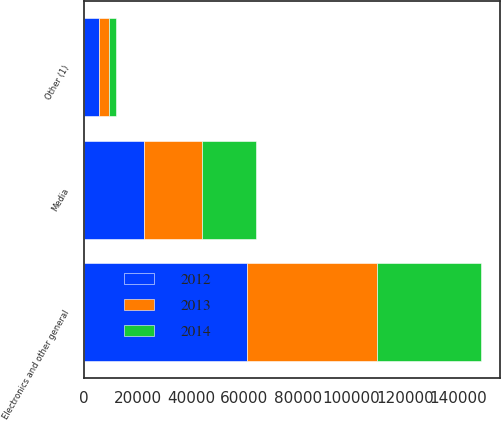Convert chart. <chart><loc_0><loc_0><loc_500><loc_500><stacked_bar_chart><ecel><fcel>Media<fcel>Electronics and other general<fcel>Other (1)<nl><fcel>2012<fcel>22505<fcel>60886<fcel>5597<nl><fcel>2013<fcel>21716<fcel>48802<fcel>3934<nl><fcel>2014<fcel>19942<fcel>38628<fcel>2523<nl></chart> 